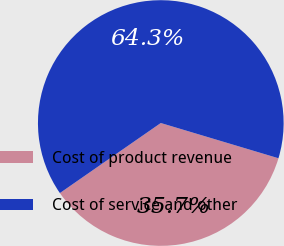<chart> <loc_0><loc_0><loc_500><loc_500><pie_chart><fcel>Cost of product revenue<fcel>Cost of service and other<nl><fcel>35.71%<fcel>64.29%<nl></chart> 